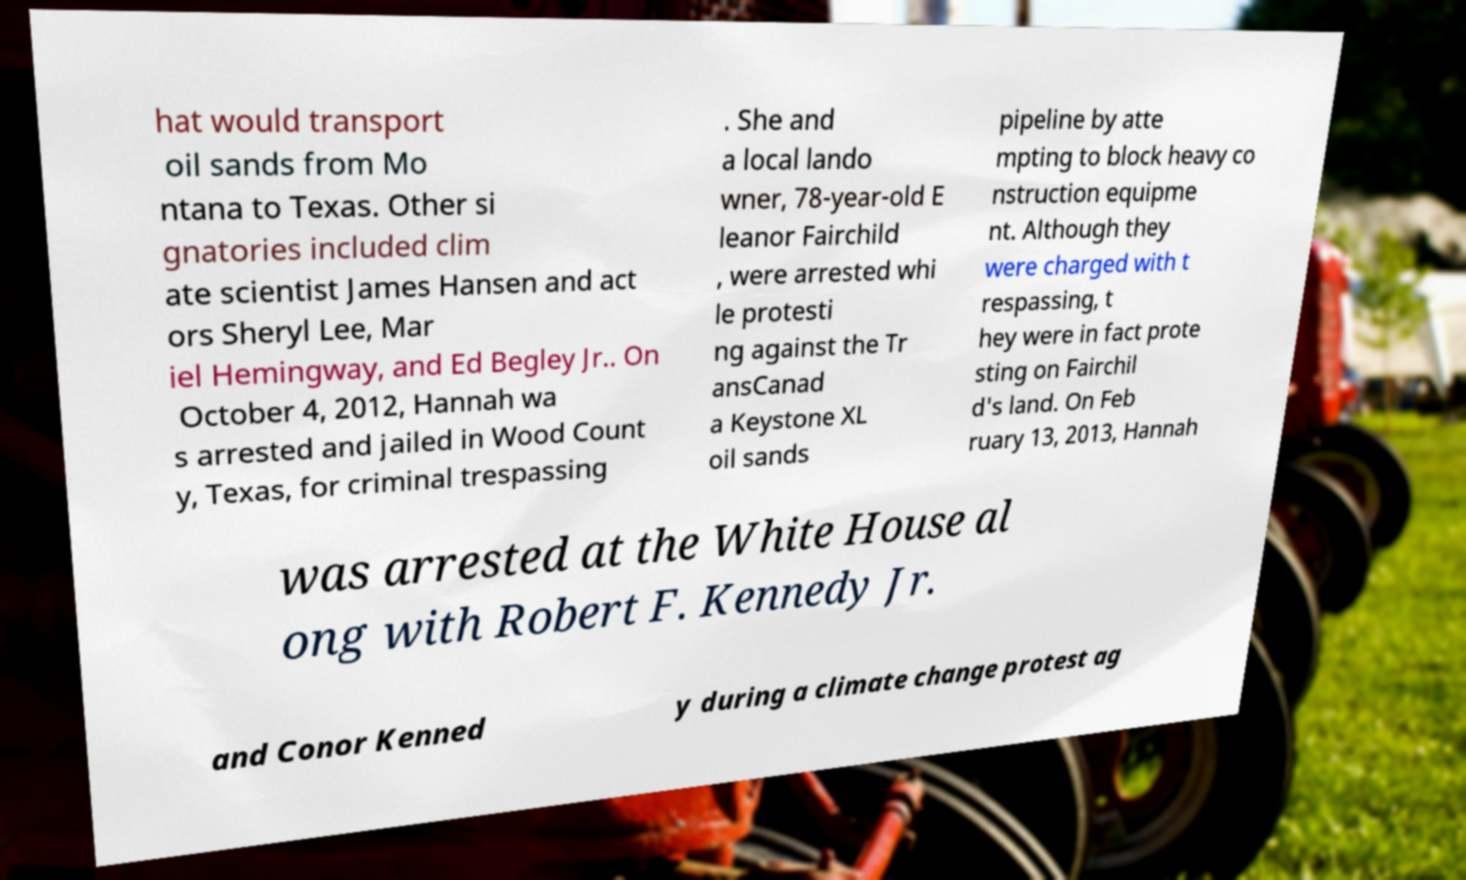Could you assist in decoding the text presented in this image and type it out clearly? hat would transport oil sands from Mo ntana to Texas. Other si gnatories included clim ate scientist James Hansen and act ors Sheryl Lee, Mar iel Hemingway, and Ed Begley Jr.. On October 4, 2012, Hannah wa s arrested and jailed in Wood Count y, Texas, for criminal trespassing . She and a local lando wner, 78-year-old E leanor Fairchild , were arrested whi le protesti ng against the Tr ansCanad a Keystone XL oil sands pipeline by atte mpting to block heavy co nstruction equipme nt. Although they were charged with t respassing, t hey were in fact prote sting on Fairchil d's land. On Feb ruary 13, 2013, Hannah was arrested at the White House al ong with Robert F. Kennedy Jr. and Conor Kenned y during a climate change protest ag 